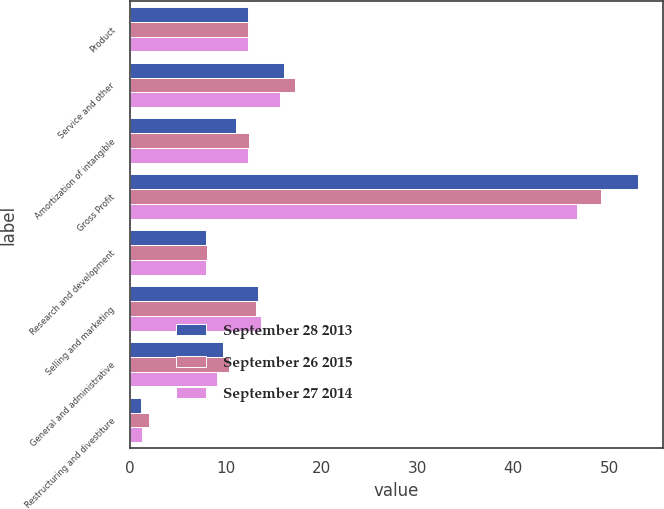Convert chart. <chart><loc_0><loc_0><loc_500><loc_500><stacked_bar_chart><ecel><fcel>Product<fcel>Service and other<fcel>Amortization of intangible<fcel>Gross Profit<fcel>Research and development<fcel>Selling and marketing<fcel>General and administrative<fcel>Restructuring and divestiture<nl><fcel>September 28 2013<fcel>12.3<fcel>16.1<fcel>11.1<fcel>53<fcel>7.9<fcel>13.4<fcel>9.7<fcel>1.1<nl><fcel>September 26 2015<fcel>12.3<fcel>17.2<fcel>12.4<fcel>49.2<fcel>8<fcel>13.1<fcel>10.3<fcel>2<nl><fcel>September 27 2014<fcel>12.3<fcel>15.7<fcel>12.3<fcel>46.6<fcel>7.9<fcel>13.7<fcel>9.1<fcel>1.3<nl></chart> 